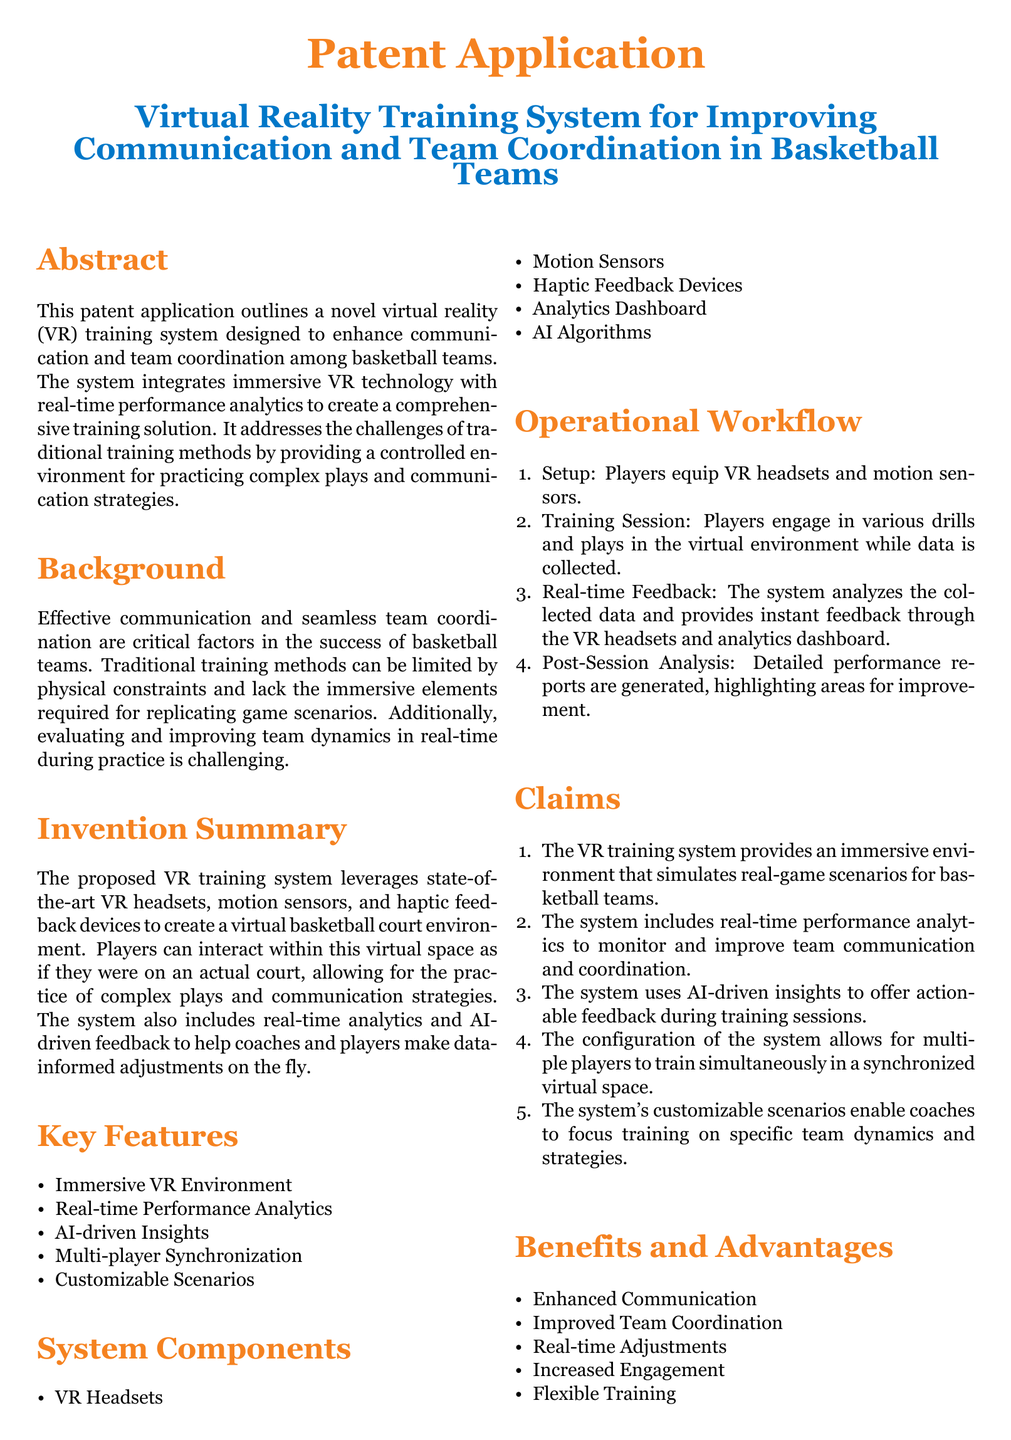What is the title of the patent application? The title is specified in the document and provides information about the focus of the invention.
Answer: Virtual Reality Training System for Improving Communication and Team Coordination in Basketball Teams What is one of the system components listed? The document lists various components that make up the system, such as VR headsets and sensors.
Answer: VR Headsets What is a key feature of the proposed VR training system? The document highlights several features that contribute to the system's functionality.
Answer: Immersive VR Environment How many steps are in the operational workflow? The document enumerates the steps involved in using the training system, aiming for clarity in its process.
Answer: Four What does the system analyze during the training session? The document specifies that the system analyzes data collected during the training to provide feedback.
Answer: Collected data What advantage does the system offer regarding team coordination? The application states the benefits of using the system to improve team dynamics during practice sessions.
Answer: Improved Team Coordination What is the purpose of the real-time performance analytics? The explanation of the system's features includes the purpose of analytics to aid training improvements.
Answer: Monitor and improve team communication and coordination Who can benefit from the virtual reality training system? The document mentions potential users of the system across different levels of basketball training.
Answer: Professional Basketball Teams What type of feedback does the system provide? The system is designed to deliver actionable details to enhance training performance in real time.
Answer: Actionable feedback during training sessions 